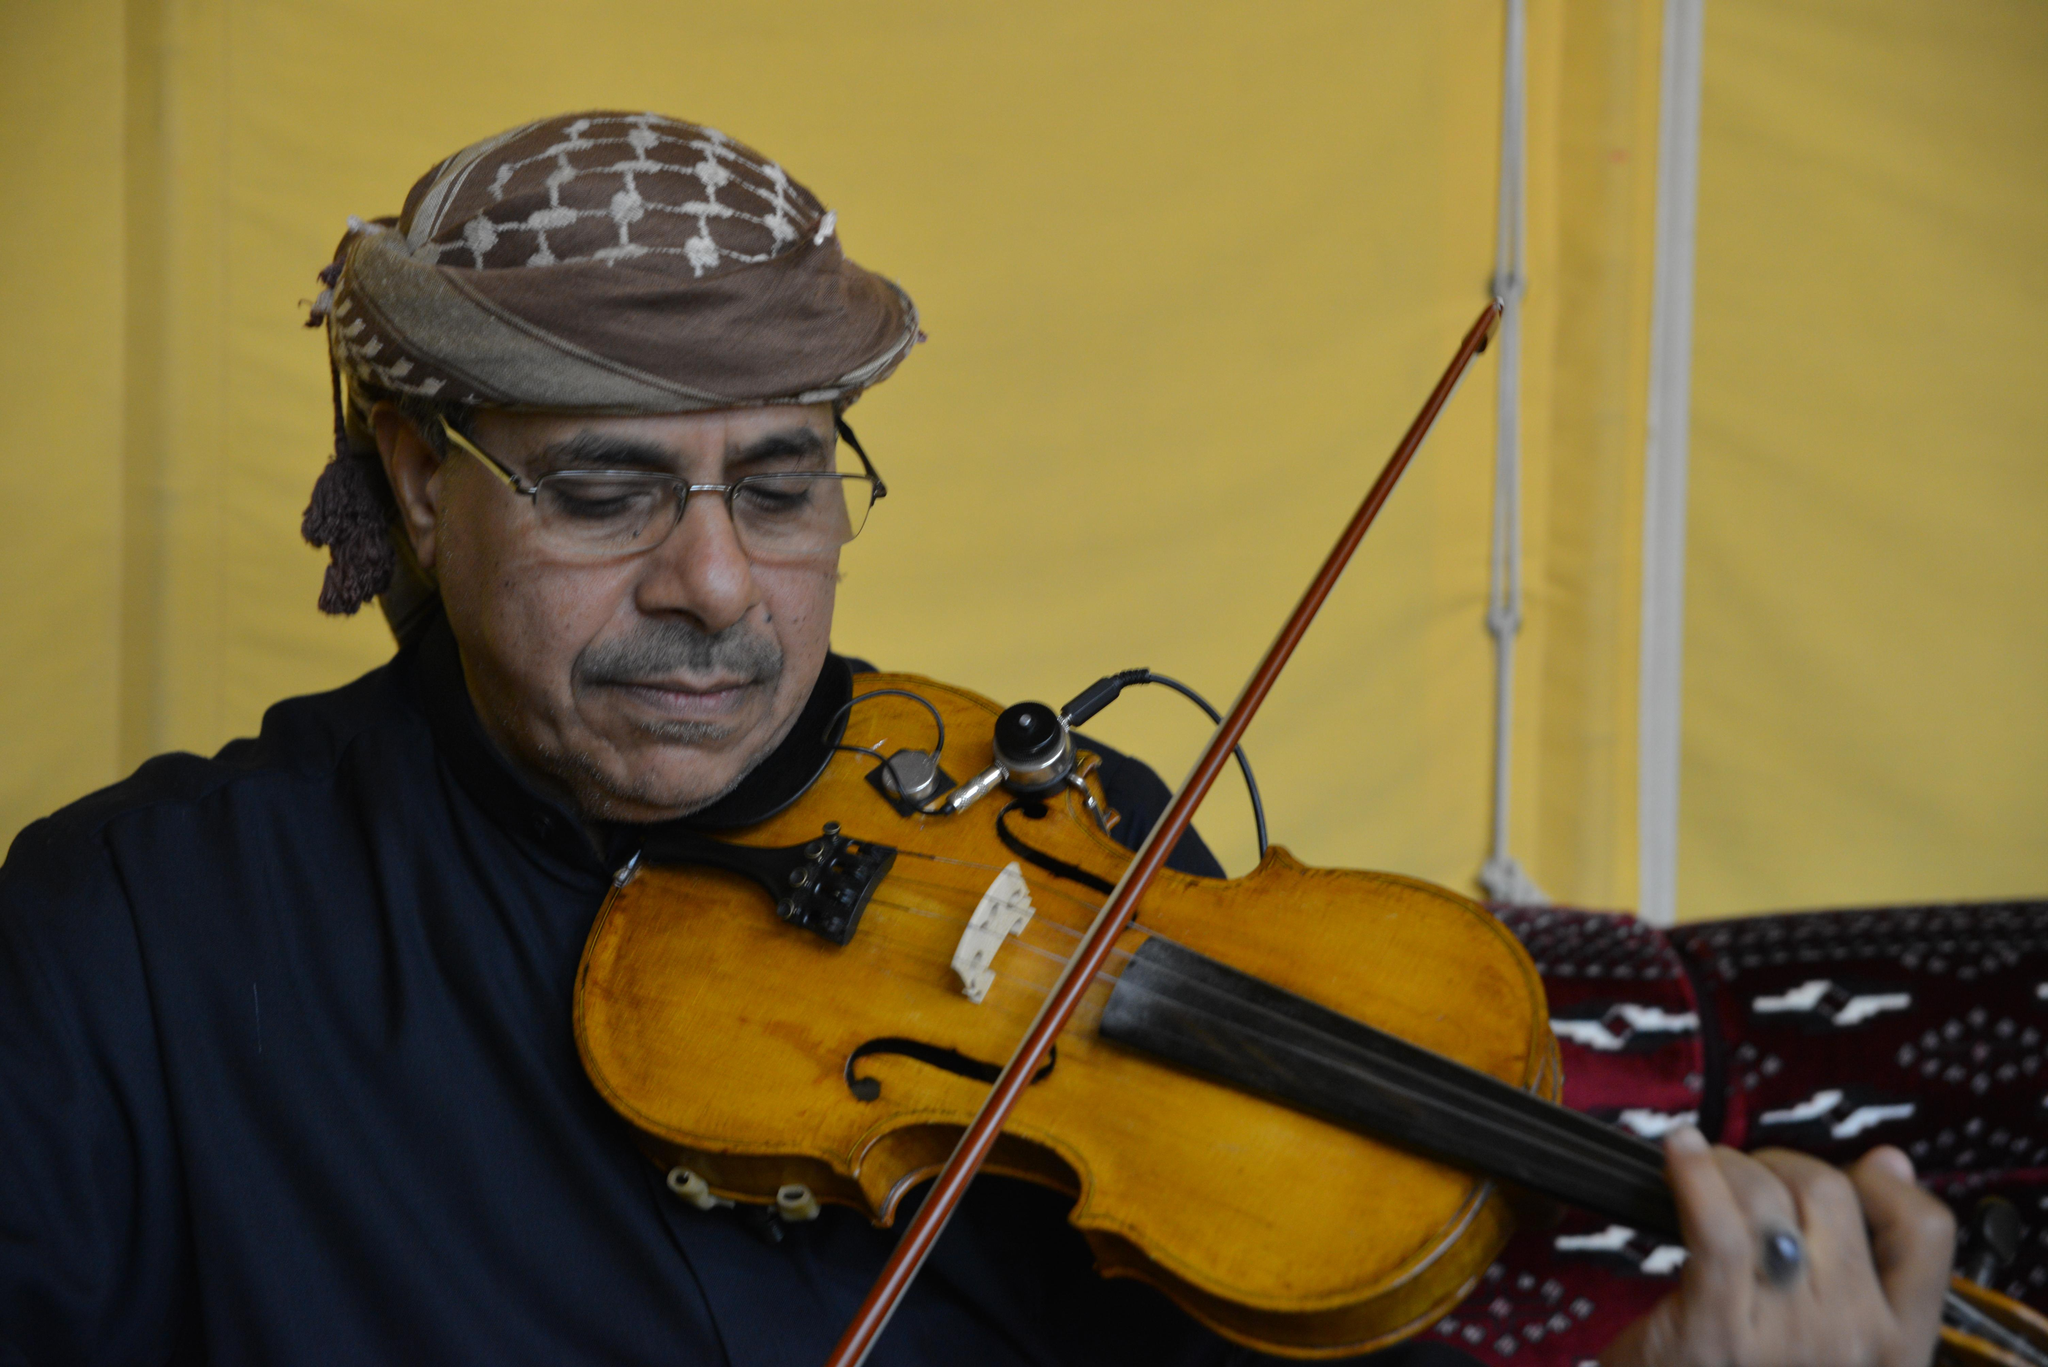Who or what is the main subject in the image? There is a person in the image. What is the person holding in the image? The person is holding a violin. What can be seen in the background of the image? There is a couch and a cloth in the background of the image. Can you see a giraffe playing the lead role in a whip-cracking performance in the image? No, there is no giraffe or whip-cracking performance present in the image. 